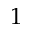<formula> <loc_0><loc_0><loc_500><loc_500>1</formula> 